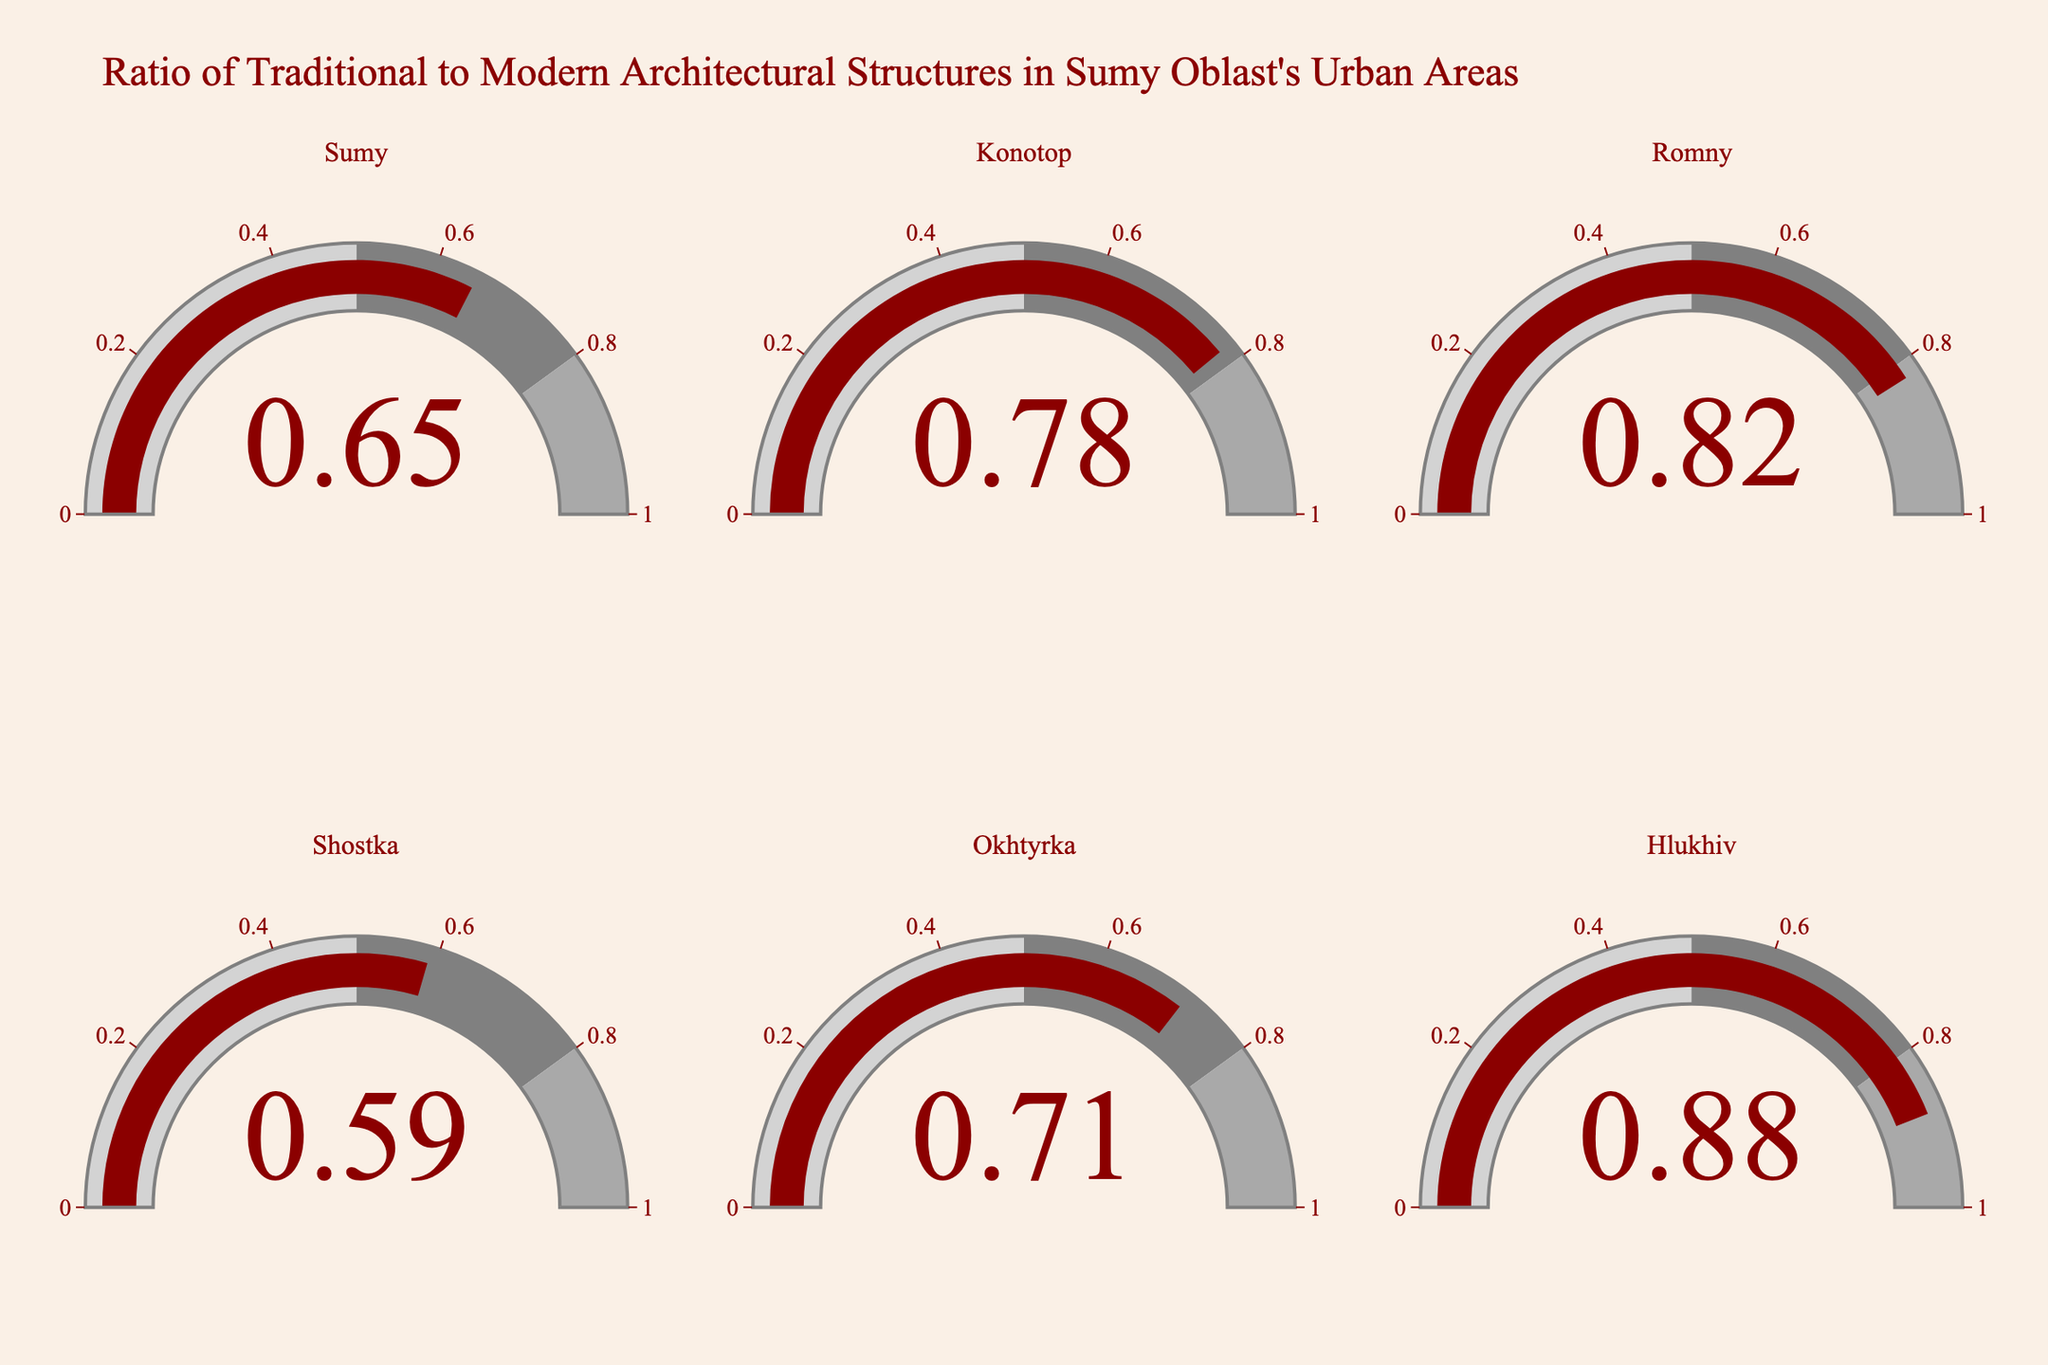What is the traditional-to-modern ratio for Hlukhiv? The gauge for Hlukhiv shows the ratio directly.
Answer: 0.88 Which city has the lowest traditional-to-modern ratio? The lowest value can be identified by comparing all the gauges. Shostka has the lowest value at 0.59.
Answer: Shostka What are the traditional-to-modern values for Sumy and Okhtyrka, and what is their difference? Sumy's value is 0.65 and Okhtyrka's is 0.71. The difference is calculated as 0.71 - 0.65.
Answer: 0.06 How many cities have a traditional-to-modern ratio greater than 0.75? By checking each city, Konotop, Romny, and Hlukhiv all have values greater than 0.75.
Answer: 3 Is the traditional ratio in Romny higher or lower than in Sumy? Romny's ratio is 0.82 and Sumy's is 0.65. Romny's ratio is higher.
Answer: Higher Which city shows a traditional-to-modern ratio nearest to 0.8? Romny has a ratio of 0.82, which is the closest to 0.8.
Answer: Romny What is the sum of the traditional-to-modern ratios for Konotop and Shostka? Konotop's value is 0.78 and Shostka's is 0.59. The sum is 0.78 + 0.59.
Answer: 1.37 Which urban area shows the highest ratio of traditional architectural structures? Hlukhiv has the highest ratio at 0.88.
Answer: Hlukhiv Are more than half of the urban areas above the 0.7 traditional-to-modern ratio? There are 6 cities in total. Sumy, Konotop, Romny, and Hlukhiv have values above 0.7, making it 4 out of 6.
Answer: Yes 